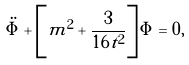Convert formula to latex. <formula><loc_0><loc_0><loc_500><loc_500>\ddot { \Phi } + \left [ m ^ { 2 } + \frac { 3 } { 1 6 t ^ { 2 } } \right ] \Phi = 0 ,</formula> 